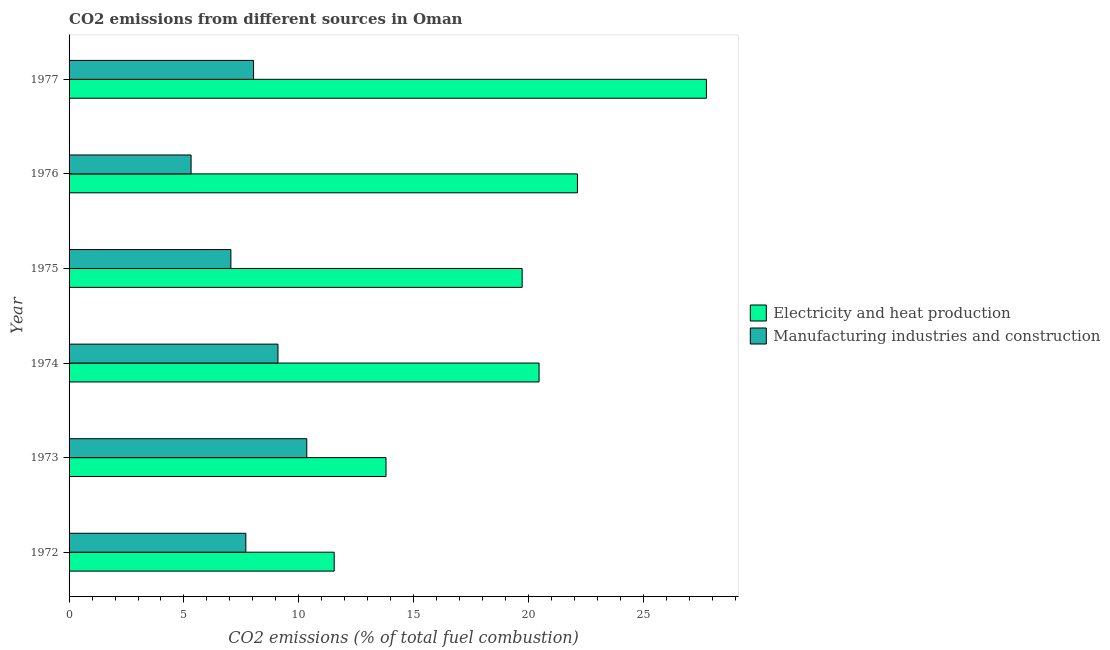Are the number of bars per tick equal to the number of legend labels?
Provide a short and direct response. Yes. How many bars are there on the 6th tick from the top?
Provide a succinct answer. 2. What is the label of the 3rd group of bars from the top?
Make the answer very short. 1975. What is the co2 emissions due to electricity and heat production in 1975?
Keep it short and to the point. 19.72. Across all years, what is the maximum co2 emissions due to manufacturing industries?
Offer a terse response. 10.34. Across all years, what is the minimum co2 emissions due to electricity and heat production?
Provide a short and direct response. 11.54. In which year was the co2 emissions due to manufacturing industries maximum?
Make the answer very short. 1973. In which year was the co2 emissions due to manufacturing industries minimum?
Offer a very short reply. 1976. What is the total co2 emissions due to manufacturing industries in the graph?
Give a very brief answer. 47.51. What is the difference between the co2 emissions due to electricity and heat production in 1973 and that in 1977?
Give a very brief answer. -13.94. What is the difference between the co2 emissions due to manufacturing industries in 1972 and the co2 emissions due to electricity and heat production in 1973?
Your answer should be very brief. -6.1. What is the average co2 emissions due to electricity and heat production per year?
Offer a terse response. 19.23. In the year 1975, what is the difference between the co2 emissions due to electricity and heat production and co2 emissions due to manufacturing industries?
Your answer should be compact. 12.68. What is the ratio of the co2 emissions due to manufacturing industries in 1973 to that in 1976?
Give a very brief answer. 1.95. Is the co2 emissions due to manufacturing industries in 1974 less than that in 1976?
Offer a very short reply. No. Is the difference between the co2 emissions due to manufacturing industries in 1976 and 1977 greater than the difference between the co2 emissions due to electricity and heat production in 1976 and 1977?
Offer a very short reply. Yes. What is the difference between the highest and the second highest co2 emissions due to electricity and heat production?
Offer a terse response. 5.61. What is the difference between the highest and the lowest co2 emissions due to manufacturing industries?
Provide a succinct answer. 5.04. In how many years, is the co2 emissions due to manufacturing industries greater than the average co2 emissions due to manufacturing industries taken over all years?
Your answer should be compact. 3. Is the sum of the co2 emissions due to electricity and heat production in 1974 and 1977 greater than the maximum co2 emissions due to manufacturing industries across all years?
Your answer should be very brief. Yes. What does the 1st bar from the top in 1974 represents?
Make the answer very short. Manufacturing industries and construction. What does the 1st bar from the bottom in 1974 represents?
Offer a very short reply. Electricity and heat production. How many bars are there?
Provide a short and direct response. 12. Are all the bars in the graph horizontal?
Your answer should be very brief. Yes. How many years are there in the graph?
Offer a terse response. 6. What is the difference between two consecutive major ticks on the X-axis?
Your answer should be very brief. 5. Are the values on the major ticks of X-axis written in scientific E-notation?
Your response must be concise. No. Does the graph contain grids?
Provide a succinct answer. No. Where does the legend appear in the graph?
Offer a very short reply. Center right. How many legend labels are there?
Ensure brevity in your answer.  2. What is the title of the graph?
Your answer should be very brief. CO2 emissions from different sources in Oman. What is the label or title of the X-axis?
Your answer should be compact. CO2 emissions (% of total fuel combustion). What is the label or title of the Y-axis?
Offer a very short reply. Year. What is the CO2 emissions (% of total fuel combustion) in Electricity and heat production in 1972?
Offer a very short reply. 11.54. What is the CO2 emissions (% of total fuel combustion) of Manufacturing industries and construction in 1972?
Your answer should be very brief. 7.69. What is the CO2 emissions (% of total fuel combustion) in Electricity and heat production in 1973?
Provide a succinct answer. 13.79. What is the CO2 emissions (% of total fuel combustion) in Manufacturing industries and construction in 1973?
Your answer should be compact. 10.34. What is the CO2 emissions (% of total fuel combustion) of Electricity and heat production in 1974?
Your answer should be compact. 20.45. What is the CO2 emissions (% of total fuel combustion) in Manufacturing industries and construction in 1974?
Offer a very short reply. 9.09. What is the CO2 emissions (% of total fuel combustion) in Electricity and heat production in 1975?
Ensure brevity in your answer.  19.72. What is the CO2 emissions (% of total fuel combustion) in Manufacturing industries and construction in 1975?
Your response must be concise. 7.04. What is the CO2 emissions (% of total fuel combustion) in Electricity and heat production in 1976?
Your answer should be very brief. 22.12. What is the CO2 emissions (% of total fuel combustion) of Manufacturing industries and construction in 1976?
Ensure brevity in your answer.  5.31. What is the CO2 emissions (% of total fuel combustion) in Electricity and heat production in 1977?
Your answer should be compact. 27.74. What is the CO2 emissions (% of total fuel combustion) of Manufacturing industries and construction in 1977?
Keep it short and to the point. 8.03. Across all years, what is the maximum CO2 emissions (% of total fuel combustion) of Electricity and heat production?
Provide a succinct answer. 27.74. Across all years, what is the maximum CO2 emissions (% of total fuel combustion) of Manufacturing industries and construction?
Give a very brief answer. 10.34. Across all years, what is the minimum CO2 emissions (% of total fuel combustion) of Electricity and heat production?
Your answer should be very brief. 11.54. Across all years, what is the minimum CO2 emissions (% of total fuel combustion) in Manufacturing industries and construction?
Provide a short and direct response. 5.31. What is the total CO2 emissions (% of total fuel combustion) of Electricity and heat production in the graph?
Your response must be concise. 115.37. What is the total CO2 emissions (% of total fuel combustion) of Manufacturing industries and construction in the graph?
Provide a short and direct response. 47.51. What is the difference between the CO2 emissions (% of total fuel combustion) in Electricity and heat production in 1972 and that in 1973?
Offer a very short reply. -2.25. What is the difference between the CO2 emissions (% of total fuel combustion) in Manufacturing industries and construction in 1972 and that in 1973?
Give a very brief answer. -2.65. What is the difference between the CO2 emissions (% of total fuel combustion) in Electricity and heat production in 1972 and that in 1974?
Offer a terse response. -8.92. What is the difference between the CO2 emissions (% of total fuel combustion) of Manufacturing industries and construction in 1972 and that in 1974?
Provide a succinct answer. -1.4. What is the difference between the CO2 emissions (% of total fuel combustion) of Electricity and heat production in 1972 and that in 1975?
Your answer should be compact. -8.18. What is the difference between the CO2 emissions (% of total fuel combustion) in Manufacturing industries and construction in 1972 and that in 1975?
Ensure brevity in your answer.  0.65. What is the difference between the CO2 emissions (% of total fuel combustion) in Electricity and heat production in 1972 and that in 1976?
Provide a succinct answer. -10.59. What is the difference between the CO2 emissions (% of total fuel combustion) of Manufacturing industries and construction in 1972 and that in 1976?
Make the answer very short. 2.38. What is the difference between the CO2 emissions (% of total fuel combustion) of Electricity and heat production in 1972 and that in 1977?
Ensure brevity in your answer.  -16.2. What is the difference between the CO2 emissions (% of total fuel combustion) in Manufacturing industries and construction in 1972 and that in 1977?
Give a very brief answer. -0.34. What is the difference between the CO2 emissions (% of total fuel combustion) of Electricity and heat production in 1973 and that in 1974?
Offer a very short reply. -6.66. What is the difference between the CO2 emissions (% of total fuel combustion) of Manufacturing industries and construction in 1973 and that in 1974?
Offer a very short reply. 1.25. What is the difference between the CO2 emissions (% of total fuel combustion) in Electricity and heat production in 1973 and that in 1975?
Keep it short and to the point. -5.93. What is the difference between the CO2 emissions (% of total fuel combustion) in Manufacturing industries and construction in 1973 and that in 1975?
Offer a very short reply. 3.3. What is the difference between the CO2 emissions (% of total fuel combustion) in Electricity and heat production in 1973 and that in 1976?
Your answer should be compact. -8.33. What is the difference between the CO2 emissions (% of total fuel combustion) in Manufacturing industries and construction in 1973 and that in 1976?
Offer a terse response. 5.04. What is the difference between the CO2 emissions (% of total fuel combustion) of Electricity and heat production in 1973 and that in 1977?
Ensure brevity in your answer.  -13.94. What is the difference between the CO2 emissions (% of total fuel combustion) of Manufacturing industries and construction in 1973 and that in 1977?
Provide a succinct answer. 2.32. What is the difference between the CO2 emissions (% of total fuel combustion) of Electricity and heat production in 1974 and that in 1975?
Give a very brief answer. 0.74. What is the difference between the CO2 emissions (% of total fuel combustion) of Manufacturing industries and construction in 1974 and that in 1975?
Offer a very short reply. 2.05. What is the difference between the CO2 emissions (% of total fuel combustion) in Electricity and heat production in 1974 and that in 1976?
Offer a very short reply. -1.67. What is the difference between the CO2 emissions (% of total fuel combustion) in Manufacturing industries and construction in 1974 and that in 1976?
Ensure brevity in your answer.  3.78. What is the difference between the CO2 emissions (% of total fuel combustion) in Electricity and heat production in 1974 and that in 1977?
Your answer should be very brief. -7.28. What is the difference between the CO2 emissions (% of total fuel combustion) in Manufacturing industries and construction in 1974 and that in 1977?
Offer a terse response. 1.06. What is the difference between the CO2 emissions (% of total fuel combustion) of Electricity and heat production in 1975 and that in 1976?
Your answer should be compact. -2.41. What is the difference between the CO2 emissions (% of total fuel combustion) of Manufacturing industries and construction in 1975 and that in 1976?
Keep it short and to the point. 1.73. What is the difference between the CO2 emissions (% of total fuel combustion) of Electricity and heat production in 1975 and that in 1977?
Offer a terse response. -8.02. What is the difference between the CO2 emissions (% of total fuel combustion) of Manufacturing industries and construction in 1975 and that in 1977?
Your answer should be very brief. -0.99. What is the difference between the CO2 emissions (% of total fuel combustion) in Electricity and heat production in 1976 and that in 1977?
Your answer should be very brief. -5.61. What is the difference between the CO2 emissions (% of total fuel combustion) in Manufacturing industries and construction in 1976 and that in 1977?
Ensure brevity in your answer.  -2.72. What is the difference between the CO2 emissions (% of total fuel combustion) of Electricity and heat production in 1972 and the CO2 emissions (% of total fuel combustion) of Manufacturing industries and construction in 1973?
Provide a short and direct response. 1.19. What is the difference between the CO2 emissions (% of total fuel combustion) in Electricity and heat production in 1972 and the CO2 emissions (% of total fuel combustion) in Manufacturing industries and construction in 1974?
Provide a short and direct response. 2.45. What is the difference between the CO2 emissions (% of total fuel combustion) of Electricity and heat production in 1972 and the CO2 emissions (% of total fuel combustion) of Manufacturing industries and construction in 1975?
Your answer should be compact. 4.5. What is the difference between the CO2 emissions (% of total fuel combustion) of Electricity and heat production in 1972 and the CO2 emissions (% of total fuel combustion) of Manufacturing industries and construction in 1976?
Your answer should be compact. 6.23. What is the difference between the CO2 emissions (% of total fuel combustion) in Electricity and heat production in 1972 and the CO2 emissions (% of total fuel combustion) in Manufacturing industries and construction in 1977?
Ensure brevity in your answer.  3.51. What is the difference between the CO2 emissions (% of total fuel combustion) of Electricity and heat production in 1973 and the CO2 emissions (% of total fuel combustion) of Manufacturing industries and construction in 1974?
Your answer should be compact. 4.7. What is the difference between the CO2 emissions (% of total fuel combustion) of Electricity and heat production in 1973 and the CO2 emissions (% of total fuel combustion) of Manufacturing industries and construction in 1975?
Your answer should be compact. 6.75. What is the difference between the CO2 emissions (% of total fuel combustion) in Electricity and heat production in 1973 and the CO2 emissions (% of total fuel combustion) in Manufacturing industries and construction in 1976?
Your answer should be compact. 8.48. What is the difference between the CO2 emissions (% of total fuel combustion) of Electricity and heat production in 1973 and the CO2 emissions (% of total fuel combustion) of Manufacturing industries and construction in 1977?
Your answer should be very brief. 5.76. What is the difference between the CO2 emissions (% of total fuel combustion) in Electricity and heat production in 1974 and the CO2 emissions (% of total fuel combustion) in Manufacturing industries and construction in 1975?
Your answer should be compact. 13.41. What is the difference between the CO2 emissions (% of total fuel combustion) of Electricity and heat production in 1974 and the CO2 emissions (% of total fuel combustion) of Manufacturing industries and construction in 1976?
Give a very brief answer. 15.14. What is the difference between the CO2 emissions (% of total fuel combustion) of Electricity and heat production in 1974 and the CO2 emissions (% of total fuel combustion) of Manufacturing industries and construction in 1977?
Make the answer very short. 12.43. What is the difference between the CO2 emissions (% of total fuel combustion) of Electricity and heat production in 1975 and the CO2 emissions (% of total fuel combustion) of Manufacturing industries and construction in 1976?
Provide a short and direct response. 14.41. What is the difference between the CO2 emissions (% of total fuel combustion) of Electricity and heat production in 1975 and the CO2 emissions (% of total fuel combustion) of Manufacturing industries and construction in 1977?
Ensure brevity in your answer.  11.69. What is the difference between the CO2 emissions (% of total fuel combustion) of Electricity and heat production in 1976 and the CO2 emissions (% of total fuel combustion) of Manufacturing industries and construction in 1977?
Your answer should be compact. 14.09. What is the average CO2 emissions (% of total fuel combustion) in Electricity and heat production per year?
Provide a succinct answer. 19.23. What is the average CO2 emissions (% of total fuel combustion) in Manufacturing industries and construction per year?
Provide a succinct answer. 7.92. In the year 1972, what is the difference between the CO2 emissions (% of total fuel combustion) in Electricity and heat production and CO2 emissions (% of total fuel combustion) in Manufacturing industries and construction?
Offer a very short reply. 3.85. In the year 1973, what is the difference between the CO2 emissions (% of total fuel combustion) of Electricity and heat production and CO2 emissions (% of total fuel combustion) of Manufacturing industries and construction?
Offer a terse response. 3.45. In the year 1974, what is the difference between the CO2 emissions (% of total fuel combustion) in Electricity and heat production and CO2 emissions (% of total fuel combustion) in Manufacturing industries and construction?
Give a very brief answer. 11.36. In the year 1975, what is the difference between the CO2 emissions (% of total fuel combustion) in Electricity and heat production and CO2 emissions (% of total fuel combustion) in Manufacturing industries and construction?
Offer a terse response. 12.68. In the year 1976, what is the difference between the CO2 emissions (% of total fuel combustion) in Electricity and heat production and CO2 emissions (% of total fuel combustion) in Manufacturing industries and construction?
Your answer should be very brief. 16.81. In the year 1977, what is the difference between the CO2 emissions (% of total fuel combustion) of Electricity and heat production and CO2 emissions (% of total fuel combustion) of Manufacturing industries and construction?
Provide a short and direct response. 19.71. What is the ratio of the CO2 emissions (% of total fuel combustion) of Electricity and heat production in 1972 to that in 1973?
Keep it short and to the point. 0.84. What is the ratio of the CO2 emissions (% of total fuel combustion) of Manufacturing industries and construction in 1972 to that in 1973?
Ensure brevity in your answer.  0.74. What is the ratio of the CO2 emissions (% of total fuel combustion) of Electricity and heat production in 1972 to that in 1974?
Offer a very short reply. 0.56. What is the ratio of the CO2 emissions (% of total fuel combustion) in Manufacturing industries and construction in 1972 to that in 1974?
Your response must be concise. 0.85. What is the ratio of the CO2 emissions (% of total fuel combustion) of Electricity and heat production in 1972 to that in 1975?
Your answer should be compact. 0.59. What is the ratio of the CO2 emissions (% of total fuel combustion) in Manufacturing industries and construction in 1972 to that in 1975?
Make the answer very short. 1.09. What is the ratio of the CO2 emissions (% of total fuel combustion) in Electricity and heat production in 1972 to that in 1976?
Provide a short and direct response. 0.52. What is the ratio of the CO2 emissions (% of total fuel combustion) of Manufacturing industries and construction in 1972 to that in 1976?
Your answer should be compact. 1.45. What is the ratio of the CO2 emissions (% of total fuel combustion) of Electricity and heat production in 1972 to that in 1977?
Your answer should be very brief. 0.42. What is the ratio of the CO2 emissions (% of total fuel combustion) of Manufacturing industries and construction in 1972 to that in 1977?
Keep it short and to the point. 0.96. What is the ratio of the CO2 emissions (% of total fuel combustion) of Electricity and heat production in 1973 to that in 1974?
Offer a very short reply. 0.67. What is the ratio of the CO2 emissions (% of total fuel combustion) in Manufacturing industries and construction in 1973 to that in 1974?
Make the answer very short. 1.14. What is the ratio of the CO2 emissions (% of total fuel combustion) in Electricity and heat production in 1973 to that in 1975?
Offer a very short reply. 0.7. What is the ratio of the CO2 emissions (% of total fuel combustion) of Manufacturing industries and construction in 1973 to that in 1975?
Your response must be concise. 1.47. What is the ratio of the CO2 emissions (% of total fuel combustion) in Electricity and heat production in 1973 to that in 1976?
Your answer should be very brief. 0.62. What is the ratio of the CO2 emissions (% of total fuel combustion) of Manufacturing industries and construction in 1973 to that in 1976?
Provide a succinct answer. 1.95. What is the ratio of the CO2 emissions (% of total fuel combustion) in Electricity and heat production in 1973 to that in 1977?
Provide a succinct answer. 0.5. What is the ratio of the CO2 emissions (% of total fuel combustion) in Manufacturing industries and construction in 1973 to that in 1977?
Provide a short and direct response. 1.29. What is the ratio of the CO2 emissions (% of total fuel combustion) of Electricity and heat production in 1974 to that in 1975?
Offer a very short reply. 1.04. What is the ratio of the CO2 emissions (% of total fuel combustion) in Manufacturing industries and construction in 1974 to that in 1975?
Provide a succinct answer. 1.29. What is the ratio of the CO2 emissions (% of total fuel combustion) of Electricity and heat production in 1974 to that in 1976?
Your answer should be compact. 0.92. What is the ratio of the CO2 emissions (% of total fuel combustion) in Manufacturing industries and construction in 1974 to that in 1976?
Keep it short and to the point. 1.71. What is the ratio of the CO2 emissions (% of total fuel combustion) in Electricity and heat production in 1974 to that in 1977?
Provide a short and direct response. 0.74. What is the ratio of the CO2 emissions (% of total fuel combustion) of Manufacturing industries and construction in 1974 to that in 1977?
Provide a short and direct response. 1.13. What is the ratio of the CO2 emissions (% of total fuel combustion) in Electricity and heat production in 1975 to that in 1976?
Provide a short and direct response. 0.89. What is the ratio of the CO2 emissions (% of total fuel combustion) in Manufacturing industries and construction in 1975 to that in 1976?
Give a very brief answer. 1.33. What is the ratio of the CO2 emissions (% of total fuel combustion) in Electricity and heat production in 1975 to that in 1977?
Ensure brevity in your answer.  0.71. What is the ratio of the CO2 emissions (% of total fuel combustion) in Manufacturing industries and construction in 1975 to that in 1977?
Your response must be concise. 0.88. What is the ratio of the CO2 emissions (% of total fuel combustion) of Electricity and heat production in 1976 to that in 1977?
Make the answer very short. 0.8. What is the ratio of the CO2 emissions (% of total fuel combustion) in Manufacturing industries and construction in 1976 to that in 1977?
Keep it short and to the point. 0.66. What is the difference between the highest and the second highest CO2 emissions (% of total fuel combustion) of Electricity and heat production?
Provide a short and direct response. 5.61. What is the difference between the highest and the second highest CO2 emissions (% of total fuel combustion) in Manufacturing industries and construction?
Keep it short and to the point. 1.25. What is the difference between the highest and the lowest CO2 emissions (% of total fuel combustion) of Electricity and heat production?
Provide a succinct answer. 16.2. What is the difference between the highest and the lowest CO2 emissions (% of total fuel combustion) of Manufacturing industries and construction?
Give a very brief answer. 5.04. 